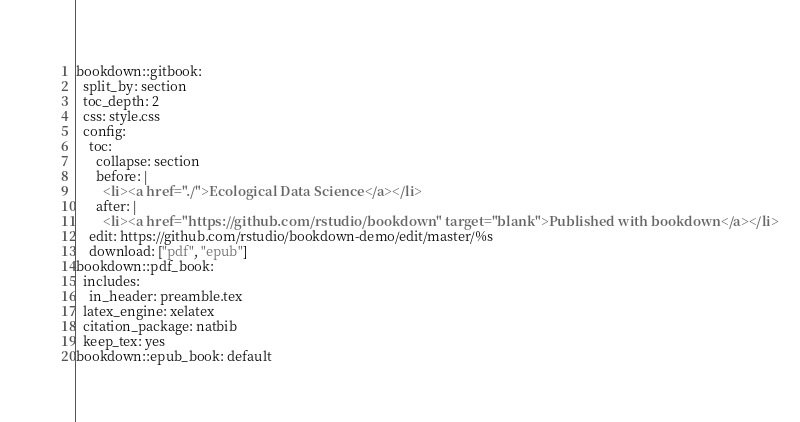<code> <loc_0><loc_0><loc_500><loc_500><_YAML_>bookdown::gitbook:
  split_by: section
  toc_depth: 2
  css: style.css
  config:
    toc:
      collapse: section
      before: |
        <li><a href="./">Ecological Data Science</a></li>
      after: |
        <li><a href="https://github.com/rstudio/bookdown" target="blank">Published with bookdown</a></li>
    edit: https://github.com/rstudio/bookdown-demo/edit/master/%s
    download: ["pdf", "epub"]
bookdown::pdf_book:
  includes:
    in_header: preamble.tex
  latex_engine: xelatex
  citation_package: natbib
  keep_tex: yes
bookdown::epub_book: default
</code> 